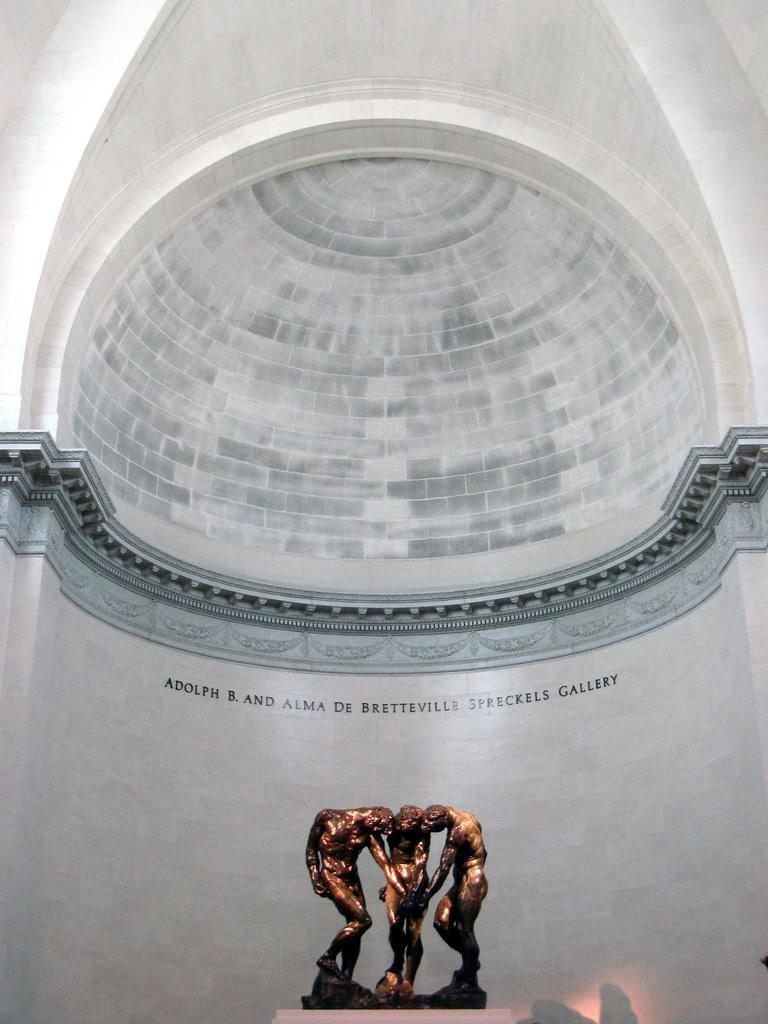Can you describe this image briefly? At the bottom of the image we can see a statue. In the background of the image we can see the text on the wall and roof. 